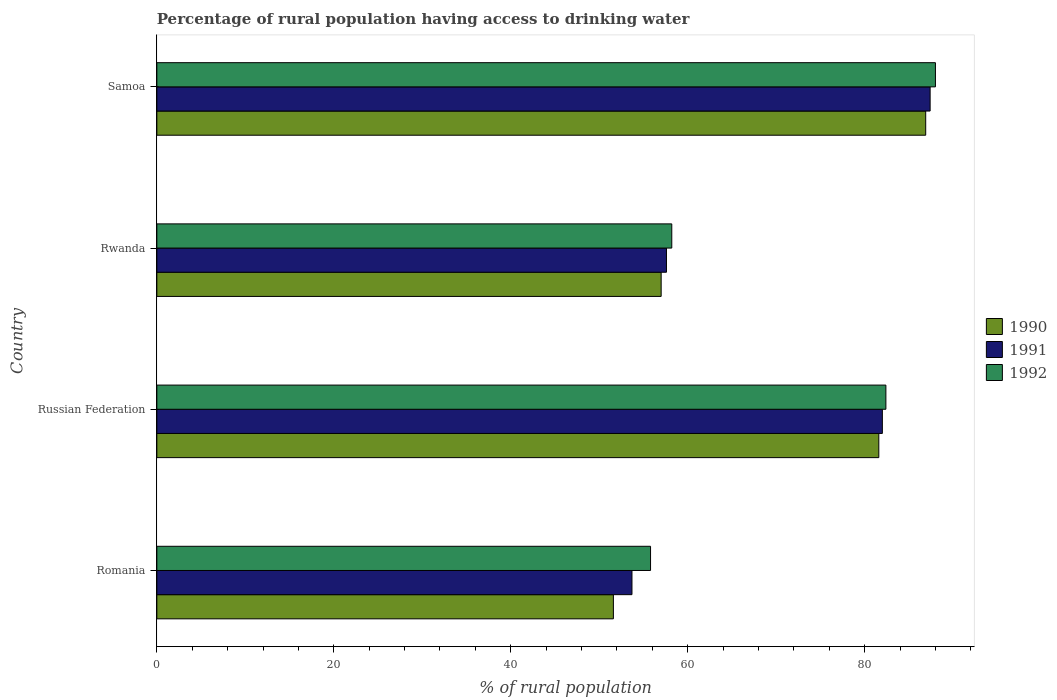Are the number of bars per tick equal to the number of legend labels?
Give a very brief answer. Yes. Are the number of bars on each tick of the Y-axis equal?
Offer a very short reply. Yes. What is the label of the 2nd group of bars from the top?
Your answer should be very brief. Rwanda. In how many cases, is the number of bars for a given country not equal to the number of legend labels?
Give a very brief answer. 0. What is the percentage of rural population having access to drinking water in 1990 in Rwanda?
Provide a succinct answer. 57. Across all countries, what is the minimum percentage of rural population having access to drinking water in 1990?
Give a very brief answer. 51.6. In which country was the percentage of rural population having access to drinking water in 1992 maximum?
Ensure brevity in your answer.  Samoa. In which country was the percentage of rural population having access to drinking water in 1992 minimum?
Provide a short and direct response. Romania. What is the total percentage of rural population having access to drinking water in 1990 in the graph?
Offer a very short reply. 277.1. What is the difference between the percentage of rural population having access to drinking water in 1991 in Romania and that in Samoa?
Offer a terse response. -33.7. What is the difference between the percentage of rural population having access to drinking water in 1992 in Romania and the percentage of rural population having access to drinking water in 1990 in Russian Federation?
Offer a very short reply. -25.8. What is the average percentage of rural population having access to drinking water in 1992 per country?
Ensure brevity in your answer.  71.1. What is the difference between the percentage of rural population having access to drinking water in 1990 and percentage of rural population having access to drinking water in 1992 in Russian Federation?
Your response must be concise. -0.8. What is the ratio of the percentage of rural population having access to drinking water in 1991 in Romania to that in Russian Federation?
Make the answer very short. 0.65. Is the percentage of rural population having access to drinking water in 1992 in Romania less than that in Rwanda?
Provide a short and direct response. Yes. What is the difference between the highest and the second highest percentage of rural population having access to drinking water in 1992?
Offer a terse response. 5.6. What is the difference between the highest and the lowest percentage of rural population having access to drinking water in 1990?
Ensure brevity in your answer.  35.3. In how many countries, is the percentage of rural population having access to drinking water in 1990 greater than the average percentage of rural population having access to drinking water in 1990 taken over all countries?
Offer a terse response. 2. How many countries are there in the graph?
Give a very brief answer. 4. Are the values on the major ticks of X-axis written in scientific E-notation?
Ensure brevity in your answer.  No. Does the graph contain any zero values?
Provide a succinct answer. No. Where does the legend appear in the graph?
Provide a short and direct response. Center right. What is the title of the graph?
Your response must be concise. Percentage of rural population having access to drinking water. What is the label or title of the X-axis?
Make the answer very short. % of rural population. What is the % of rural population in 1990 in Romania?
Make the answer very short. 51.6. What is the % of rural population of 1991 in Romania?
Provide a succinct answer. 53.7. What is the % of rural population in 1992 in Romania?
Ensure brevity in your answer.  55.8. What is the % of rural population in 1990 in Russian Federation?
Offer a terse response. 81.6. What is the % of rural population of 1992 in Russian Federation?
Your answer should be very brief. 82.4. What is the % of rural population in 1991 in Rwanda?
Provide a short and direct response. 57.6. What is the % of rural population of 1992 in Rwanda?
Your response must be concise. 58.2. What is the % of rural population in 1990 in Samoa?
Provide a short and direct response. 86.9. What is the % of rural population of 1991 in Samoa?
Your answer should be very brief. 87.4. Across all countries, what is the maximum % of rural population of 1990?
Provide a short and direct response. 86.9. Across all countries, what is the maximum % of rural population in 1991?
Offer a very short reply. 87.4. Across all countries, what is the minimum % of rural population in 1990?
Your answer should be compact. 51.6. Across all countries, what is the minimum % of rural population in 1991?
Provide a succinct answer. 53.7. Across all countries, what is the minimum % of rural population of 1992?
Offer a very short reply. 55.8. What is the total % of rural population of 1990 in the graph?
Provide a short and direct response. 277.1. What is the total % of rural population in 1991 in the graph?
Your response must be concise. 280.7. What is the total % of rural population in 1992 in the graph?
Keep it short and to the point. 284.4. What is the difference between the % of rural population in 1990 in Romania and that in Russian Federation?
Keep it short and to the point. -30. What is the difference between the % of rural population of 1991 in Romania and that in Russian Federation?
Offer a terse response. -28.3. What is the difference between the % of rural population in 1992 in Romania and that in Russian Federation?
Your answer should be very brief. -26.6. What is the difference between the % of rural population in 1990 in Romania and that in Rwanda?
Ensure brevity in your answer.  -5.4. What is the difference between the % of rural population of 1991 in Romania and that in Rwanda?
Keep it short and to the point. -3.9. What is the difference between the % of rural population in 1992 in Romania and that in Rwanda?
Keep it short and to the point. -2.4. What is the difference between the % of rural population in 1990 in Romania and that in Samoa?
Make the answer very short. -35.3. What is the difference between the % of rural population in 1991 in Romania and that in Samoa?
Keep it short and to the point. -33.7. What is the difference between the % of rural population of 1992 in Romania and that in Samoa?
Provide a short and direct response. -32.2. What is the difference between the % of rural population in 1990 in Russian Federation and that in Rwanda?
Offer a very short reply. 24.6. What is the difference between the % of rural population of 1991 in Russian Federation and that in Rwanda?
Offer a very short reply. 24.4. What is the difference between the % of rural population of 1992 in Russian Federation and that in Rwanda?
Offer a terse response. 24.2. What is the difference between the % of rural population of 1991 in Russian Federation and that in Samoa?
Offer a very short reply. -5.4. What is the difference between the % of rural population of 1990 in Rwanda and that in Samoa?
Provide a succinct answer. -29.9. What is the difference between the % of rural population of 1991 in Rwanda and that in Samoa?
Keep it short and to the point. -29.8. What is the difference between the % of rural population of 1992 in Rwanda and that in Samoa?
Your response must be concise. -29.8. What is the difference between the % of rural population in 1990 in Romania and the % of rural population in 1991 in Russian Federation?
Provide a short and direct response. -30.4. What is the difference between the % of rural population in 1990 in Romania and the % of rural population in 1992 in Russian Federation?
Offer a very short reply. -30.8. What is the difference between the % of rural population in 1991 in Romania and the % of rural population in 1992 in Russian Federation?
Your answer should be compact. -28.7. What is the difference between the % of rural population of 1990 in Romania and the % of rural population of 1991 in Rwanda?
Provide a short and direct response. -6. What is the difference between the % of rural population of 1990 in Romania and the % of rural population of 1991 in Samoa?
Your answer should be compact. -35.8. What is the difference between the % of rural population of 1990 in Romania and the % of rural population of 1992 in Samoa?
Keep it short and to the point. -36.4. What is the difference between the % of rural population in 1991 in Romania and the % of rural population in 1992 in Samoa?
Offer a very short reply. -34.3. What is the difference between the % of rural population of 1990 in Russian Federation and the % of rural population of 1991 in Rwanda?
Offer a very short reply. 24. What is the difference between the % of rural population of 1990 in Russian Federation and the % of rural population of 1992 in Rwanda?
Give a very brief answer. 23.4. What is the difference between the % of rural population in 1991 in Russian Federation and the % of rural population in 1992 in Rwanda?
Make the answer very short. 23.8. What is the difference between the % of rural population of 1990 in Russian Federation and the % of rural population of 1992 in Samoa?
Give a very brief answer. -6.4. What is the difference between the % of rural population of 1990 in Rwanda and the % of rural population of 1991 in Samoa?
Ensure brevity in your answer.  -30.4. What is the difference between the % of rural population in 1990 in Rwanda and the % of rural population in 1992 in Samoa?
Your response must be concise. -31. What is the difference between the % of rural population of 1991 in Rwanda and the % of rural population of 1992 in Samoa?
Keep it short and to the point. -30.4. What is the average % of rural population in 1990 per country?
Ensure brevity in your answer.  69.28. What is the average % of rural population in 1991 per country?
Keep it short and to the point. 70.17. What is the average % of rural population in 1992 per country?
Offer a terse response. 71.1. What is the difference between the % of rural population in 1990 and % of rural population in 1991 in Romania?
Make the answer very short. -2.1. What is the difference between the % of rural population of 1990 and % of rural population of 1992 in Romania?
Your answer should be very brief. -4.2. What is the difference between the % of rural population of 1991 and % of rural population of 1992 in Russian Federation?
Ensure brevity in your answer.  -0.4. What is the difference between the % of rural population of 1990 and % of rural population of 1991 in Rwanda?
Make the answer very short. -0.6. What is the difference between the % of rural population of 1991 and % of rural population of 1992 in Samoa?
Provide a succinct answer. -0.6. What is the ratio of the % of rural population in 1990 in Romania to that in Russian Federation?
Provide a succinct answer. 0.63. What is the ratio of the % of rural population of 1991 in Romania to that in Russian Federation?
Make the answer very short. 0.65. What is the ratio of the % of rural population in 1992 in Romania to that in Russian Federation?
Offer a terse response. 0.68. What is the ratio of the % of rural population in 1990 in Romania to that in Rwanda?
Provide a short and direct response. 0.91. What is the ratio of the % of rural population of 1991 in Romania to that in Rwanda?
Your answer should be very brief. 0.93. What is the ratio of the % of rural population in 1992 in Romania to that in Rwanda?
Keep it short and to the point. 0.96. What is the ratio of the % of rural population in 1990 in Romania to that in Samoa?
Offer a very short reply. 0.59. What is the ratio of the % of rural population of 1991 in Romania to that in Samoa?
Provide a succinct answer. 0.61. What is the ratio of the % of rural population in 1992 in Romania to that in Samoa?
Your response must be concise. 0.63. What is the ratio of the % of rural population in 1990 in Russian Federation to that in Rwanda?
Offer a terse response. 1.43. What is the ratio of the % of rural population of 1991 in Russian Federation to that in Rwanda?
Ensure brevity in your answer.  1.42. What is the ratio of the % of rural population in 1992 in Russian Federation to that in Rwanda?
Keep it short and to the point. 1.42. What is the ratio of the % of rural population in 1990 in Russian Federation to that in Samoa?
Keep it short and to the point. 0.94. What is the ratio of the % of rural population in 1991 in Russian Federation to that in Samoa?
Give a very brief answer. 0.94. What is the ratio of the % of rural population in 1992 in Russian Federation to that in Samoa?
Offer a terse response. 0.94. What is the ratio of the % of rural population in 1990 in Rwanda to that in Samoa?
Ensure brevity in your answer.  0.66. What is the ratio of the % of rural population in 1991 in Rwanda to that in Samoa?
Provide a succinct answer. 0.66. What is the ratio of the % of rural population of 1992 in Rwanda to that in Samoa?
Provide a succinct answer. 0.66. What is the difference between the highest and the second highest % of rural population of 1990?
Keep it short and to the point. 5.3. What is the difference between the highest and the second highest % of rural population of 1991?
Your answer should be compact. 5.4. What is the difference between the highest and the second highest % of rural population in 1992?
Give a very brief answer. 5.6. What is the difference between the highest and the lowest % of rural population in 1990?
Your answer should be very brief. 35.3. What is the difference between the highest and the lowest % of rural population of 1991?
Your response must be concise. 33.7. What is the difference between the highest and the lowest % of rural population of 1992?
Your response must be concise. 32.2. 